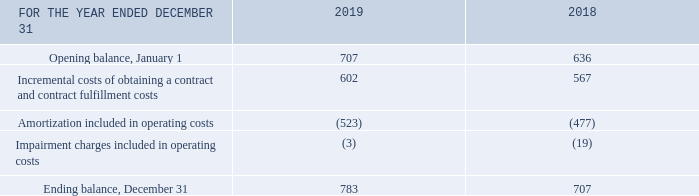Note 13 Contract costs
The table below provides a reconciliation of the contract costs balance.
Contract costs are amortized over a period ranging from 12 to 84 months.
What is the range of periods for contract cost amortization? 12 to 84 months. What is the opening balance in 2019? 707. What is the ending balance in 2019? 783. What is the difference in the opening and ending balances in 2019? 783-707
Answer: 76. What is the total incremental costs of obtaining a contract and contract fulfillment costs in 2018 and 2019? 602+567
Answer: 1169. What is the change in the incremental costs of obtaining a contract and contract fulfillment costs in 2018 to 2019? 602-567
Answer: 35. 